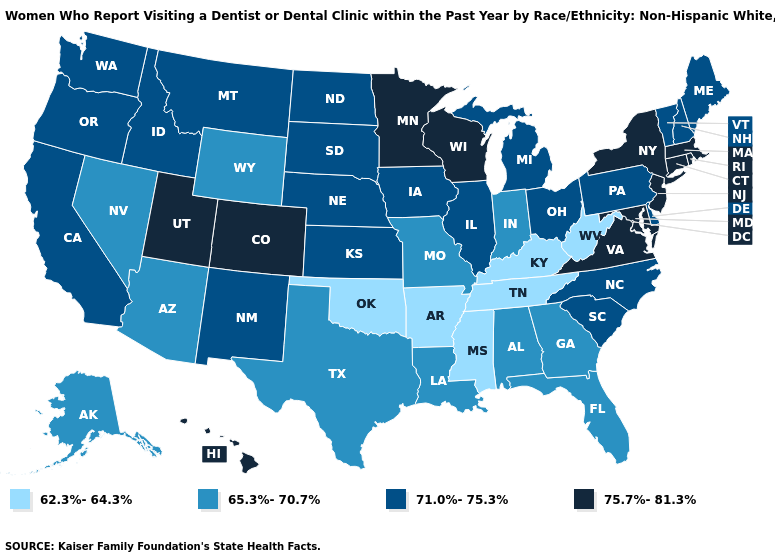Name the states that have a value in the range 62.3%-64.3%?
Be succinct. Arkansas, Kentucky, Mississippi, Oklahoma, Tennessee, West Virginia. Among the states that border Colorado , which have the lowest value?
Write a very short answer. Oklahoma. Name the states that have a value in the range 75.7%-81.3%?
Write a very short answer. Colorado, Connecticut, Hawaii, Maryland, Massachusetts, Minnesota, New Jersey, New York, Rhode Island, Utah, Virginia, Wisconsin. What is the lowest value in the Northeast?
Answer briefly. 71.0%-75.3%. Among the states that border Nebraska , does Iowa have the lowest value?
Give a very brief answer. No. Which states hav the highest value in the West?
Be succinct. Colorado, Hawaii, Utah. Does Oregon have the lowest value in the West?
Give a very brief answer. No. What is the highest value in the USA?
Be succinct. 75.7%-81.3%. What is the value of Hawaii?
Keep it brief. 75.7%-81.3%. Which states have the lowest value in the USA?
Keep it brief. Arkansas, Kentucky, Mississippi, Oklahoma, Tennessee, West Virginia. Which states have the highest value in the USA?
Be succinct. Colorado, Connecticut, Hawaii, Maryland, Massachusetts, Minnesota, New Jersey, New York, Rhode Island, Utah, Virginia, Wisconsin. What is the value of Nebraska?
Short answer required. 71.0%-75.3%. Name the states that have a value in the range 65.3%-70.7%?
Concise answer only. Alabama, Alaska, Arizona, Florida, Georgia, Indiana, Louisiana, Missouri, Nevada, Texas, Wyoming. Name the states that have a value in the range 71.0%-75.3%?
Give a very brief answer. California, Delaware, Idaho, Illinois, Iowa, Kansas, Maine, Michigan, Montana, Nebraska, New Hampshire, New Mexico, North Carolina, North Dakota, Ohio, Oregon, Pennsylvania, South Carolina, South Dakota, Vermont, Washington. Among the states that border North Carolina , does South Carolina have the highest value?
Quick response, please. No. 